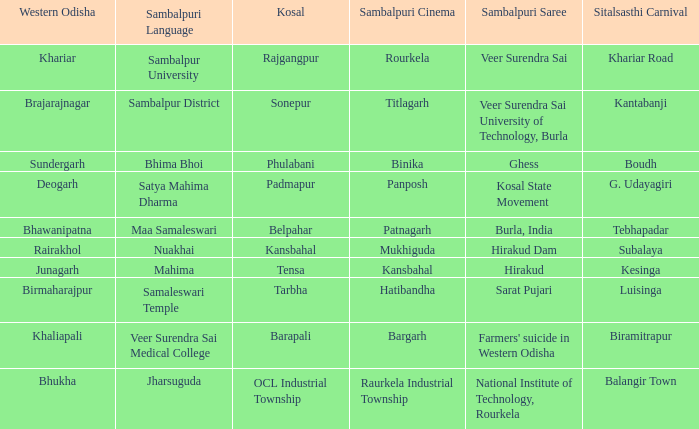What is the Kosal with a balangir town sitalsasthi carnival? OCL Industrial Township. 